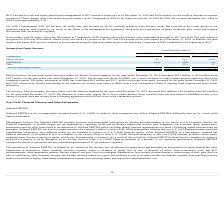According to Hc2 Holdings's financial document, What was the decrease in the income from equity investees in December 2019? According to the financial document, $14.1 million. The relevant text states: "ent for the year ended December 31, 2019 decreased $14.1 million to $5.6 million from $19.7 million for the year ended year ended December 31, 2018. The decrease was..." Also, What was the amount contributed by the equity investment in HMN in 2019? According to the financial document, $5.0 million. The relevant text states: "riod. The equity investment in HMN has contributed $5.0 million and $12.7 million in income from equity investees for the years ended December 31, 2019 and 2018, re..." Also, What was the loss from equity investees for the year ended December 2019? According to the financial document, $0.6 million. The relevant text states: "ent for the year ended December 31, 2019 decreased $0.6 million to $3.4 million from $4.0 million for the year ended December 31, 2018. The decrease in losses were..." Also, can you calculate: What was the percentage change in the marine services from 2018 to 2019? To answer this question, I need to perform calculations using the financial data. The calculation is: 5.6 / 19.7 - 1, which equals -71.57 (percentage). This is based on the information: "Marine Services 5.6 19.7 (14.1) Marine Services 5.6 19.7 (14.1)..." The key data points involved are: 19.7, 5.6. Also, can you calculate: What is the average life sciences value for 2018 and 2019? To answer this question, I need to perform calculations using the financial data. The calculation is: -(3.4 + 4.0) / 2, which equals -3.7 (in millions). This is based on the information: "Life Sciences (3.4) (4.0) 0.6 Life Sciences (3.4) (4.0) 0.6..." The key data points involved are: 3.4, 4.0. Also, can you calculate: What is the percentage change in the income from equity investees from 2018 to 2019? To answer this question, I need to perform calculations using the financial data. The calculation is: 2.2 / 15.4 - 1, which equals -85.71 (percentage). This is based on the information: "Income from equity investees $ 2.2 $ 15.4 $ (13.2) Income from equity investees $ 2.2 $ 15.4 $ (13.2)..." The key data points involved are: 15.4, 2.2. 